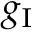<formula> <loc_0><loc_0><loc_500><loc_500>g _ { I }</formula> 